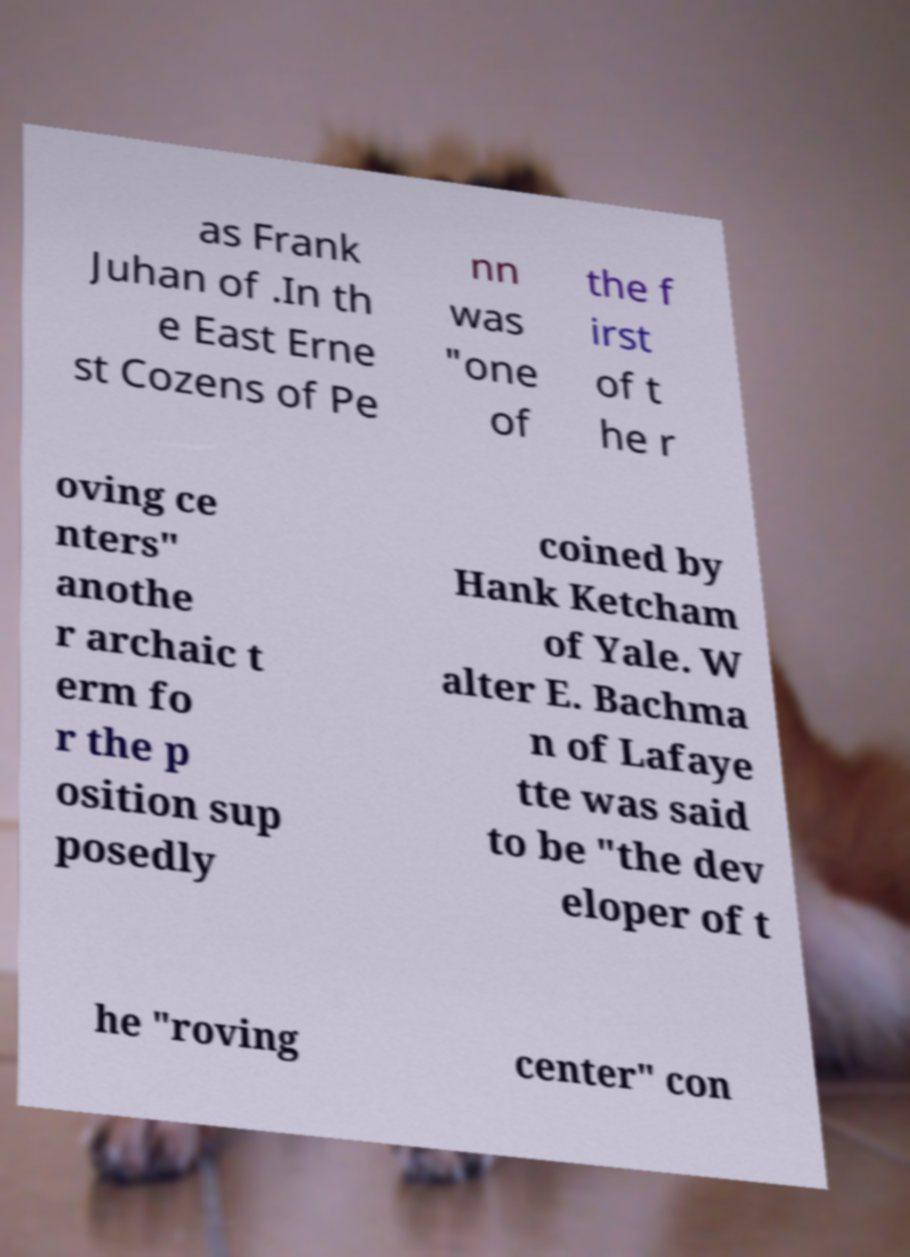There's text embedded in this image that I need extracted. Can you transcribe it verbatim? as Frank Juhan of .In th e East Erne st Cozens of Pe nn was "one of the f irst of t he r oving ce nters" anothe r archaic t erm fo r the p osition sup posedly coined by Hank Ketcham of Yale. W alter E. Bachma n of Lafaye tte was said to be "the dev eloper of t he "roving center" con 